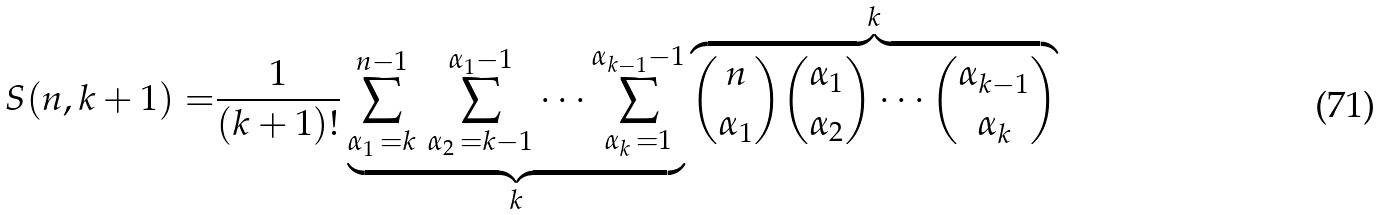<formula> <loc_0><loc_0><loc_500><loc_500>S ( n , k + 1 ) = & \frac { 1 } { ( k + 1 ) ! } \underbrace { \sum _ { \alpha _ { 1 } \, = k } ^ { n - 1 } \, \sum _ { \alpha _ { 2 } \, = k - 1 } ^ { \alpha _ { 1 } - 1 } \cdots \sum _ { \alpha _ { k } \, = 1 } ^ { \alpha _ { k - 1 } - 1 } } _ { k } \overbrace { \binom { n } { \alpha _ { 1 } } \binom { \alpha _ { 1 } } { \alpha _ { 2 } } \cdots \binom { \alpha _ { k - 1 } } { \alpha _ { k } } } ^ { k }</formula> 